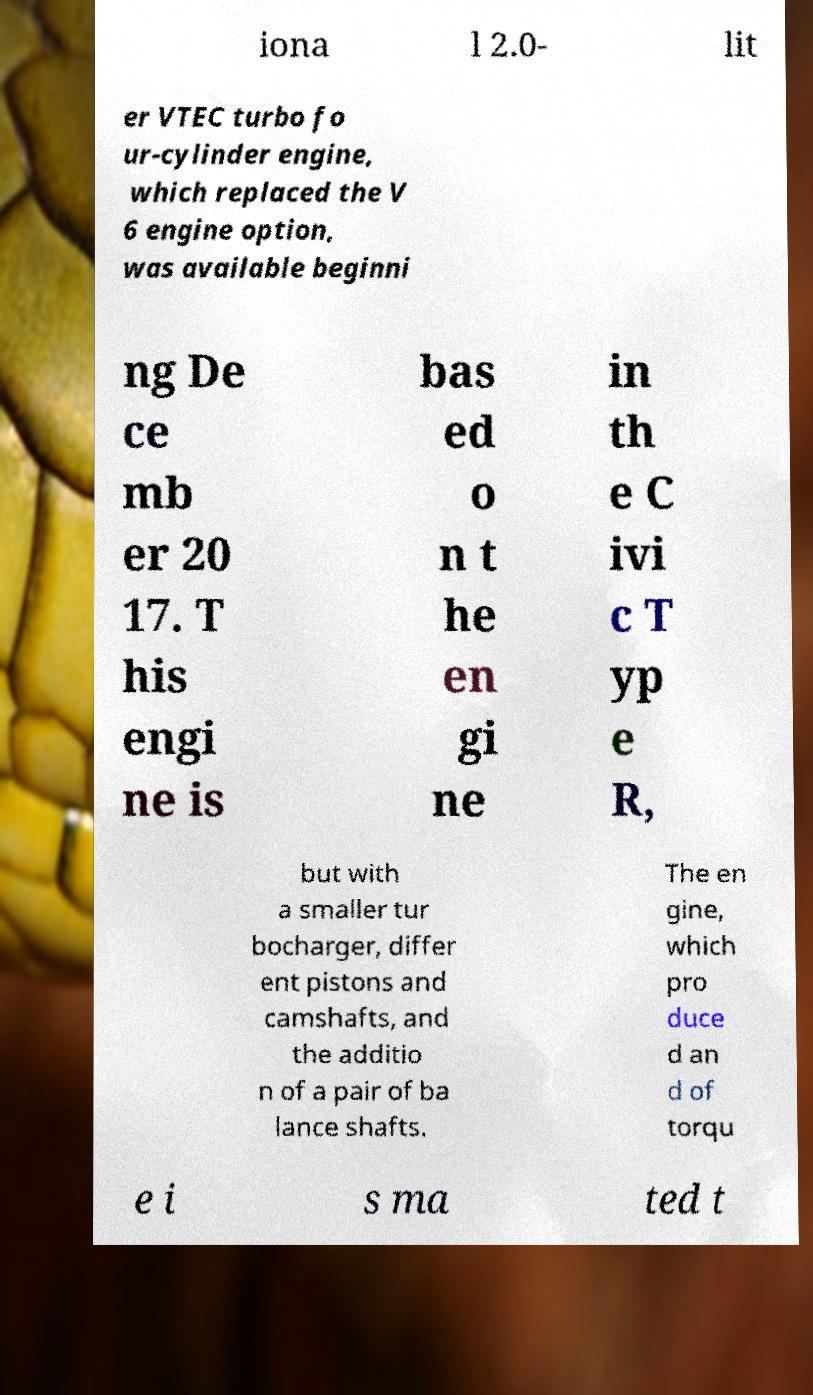Can you accurately transcribe the text from the provided image for me? iona l 2.0- lit er VTEC turbo fo ur-cylinder engine, which replaced the V 6 engine option, was available beginni ng De ce mb er 20 17. T his engi ne is bas ed o n t he en gi ne in th e C ivi c T yp e R, but with a smaller tur bocharger, differ ent pistons and camshafts, and the additio n of a pair of ba lance shafts. The en gine, which pro duce d an d of torqu e i s ma ted t 